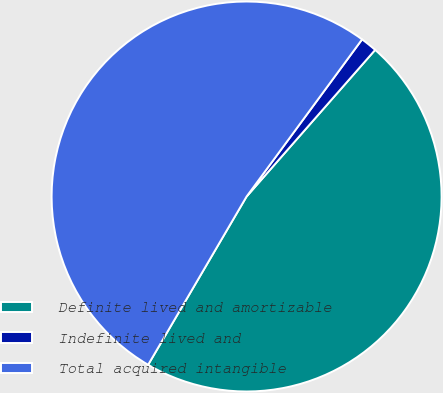<chart> <loc_0><loc_0><loc_500><loc_500><pie_chart><fcel>Definite lived and amortizable<fcel>Indefinite lived and<fcel>Total acquired intangible<nl><fcel>46.97%<fcel>1.37%<fcel>51.66%<nl></chart> 